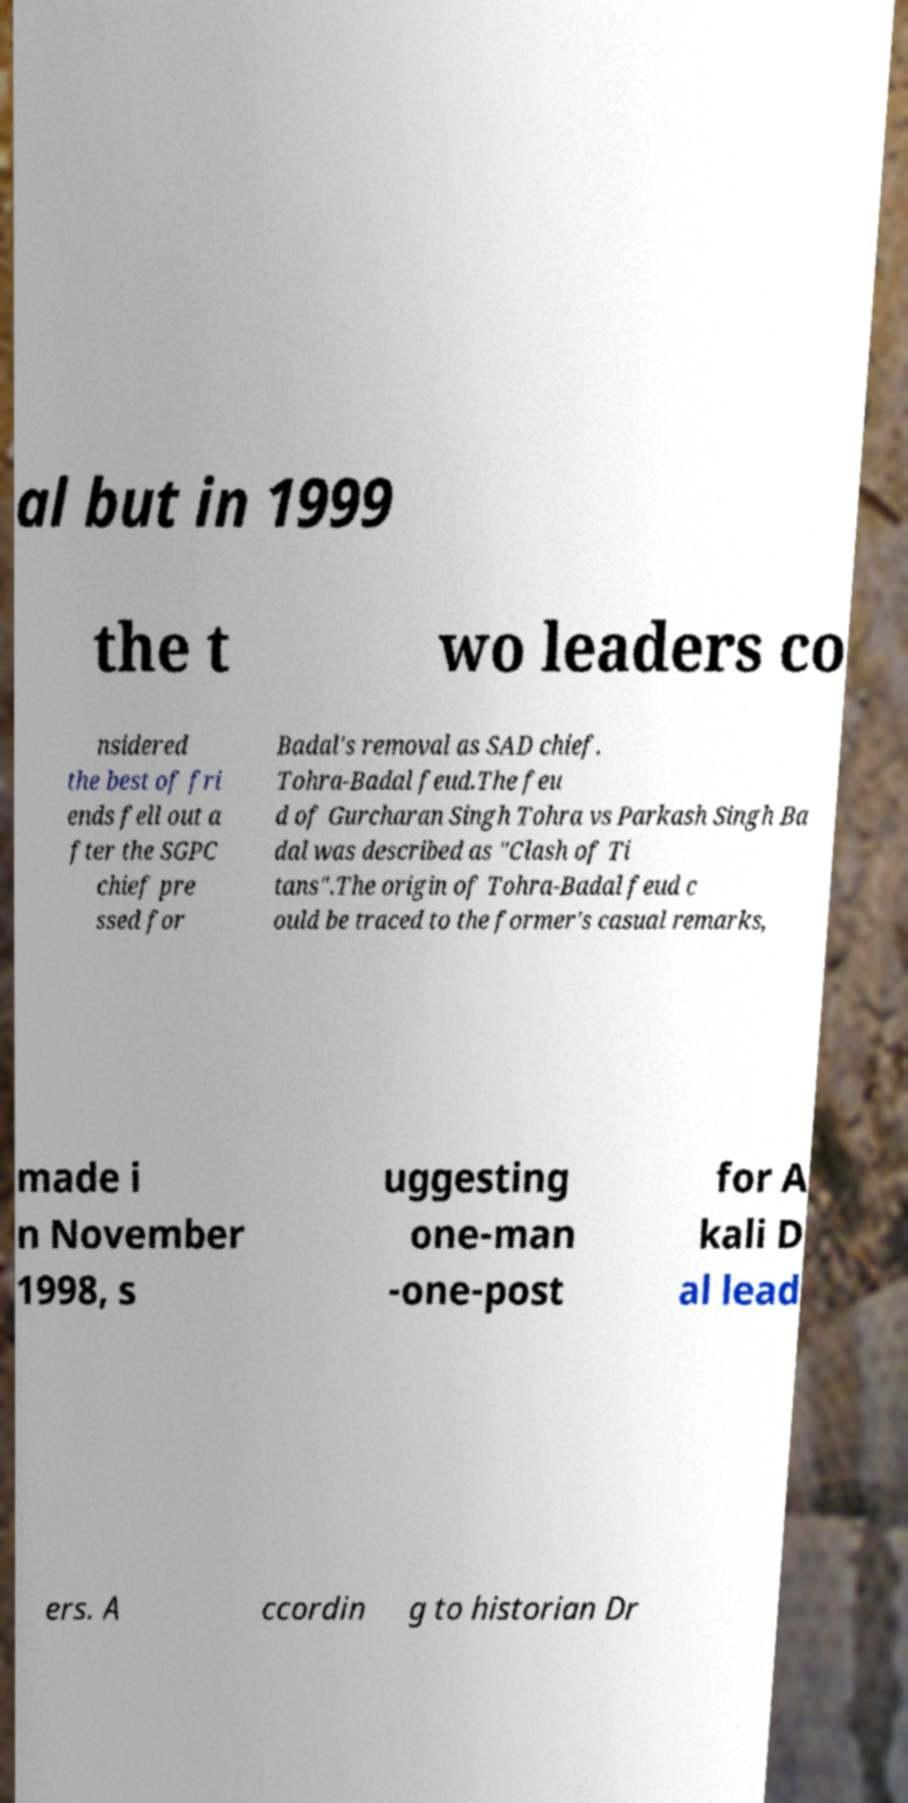Please read and relay the text visible in this image. What does it say? al but in 1999 the t wo leaders co nsidered the best of fri ends fell out a fter the SGPC chief pre ssed for Badal's removal as SAD chief. Tohra-Badal feud.The feu d of Gurcharan Singh Tohra vs Parkash Singh Ba dal was described as "Clash of Ti tans".The origin of Tohra-Badal feud c ould be traced to the former's casual remarks, made i n November 1998, s uggesting one-man -one-post for A kali D al lead ers. A ccordin g to historian Dr 